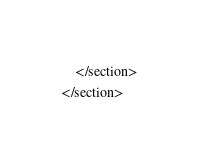Convert code to text. <code><loc_0><loc_0><loc_500><loc_500><_XML_>	</section>
</section>
</code> 